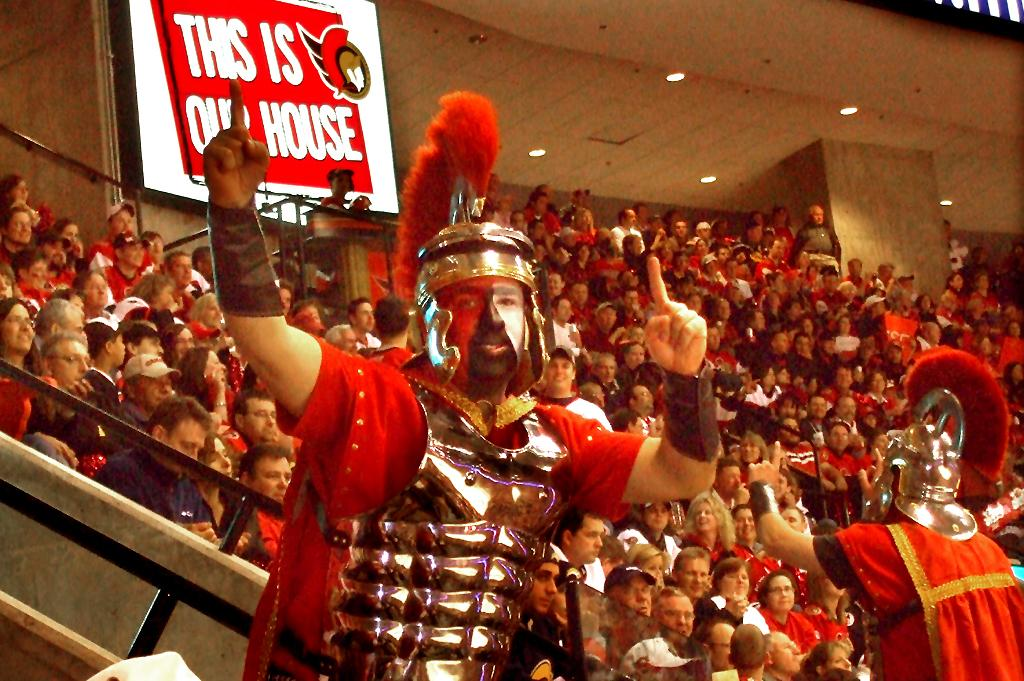What are the people in the image doing? The people in the image are sitting. Can you describe the person in the middle of the image? There is a person standing in the middle of the image. What type of quartz can be seen in the image? There is no quartz present in the image. What nation is represented by the people in the image? The image does not provide information about the nationality of the people. 